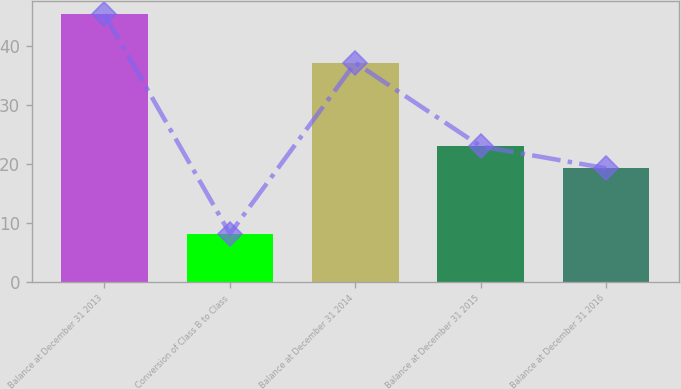Convert chart to OTSL. <chart><loc_0><loc_0><loc_500><loc_500><bar_chart><fcel>Balance at December 31 2013<fcel>Conversion of Class B to Class<fcel>Balance at December 31 2014<fcel>Balance at December 31 2015<fcel>Balance at December 31 2016<nl><fcel>45.4<fcel>8.2<fcel>37.2<fcel>23.02<fcel>19.3<nl></chart> 